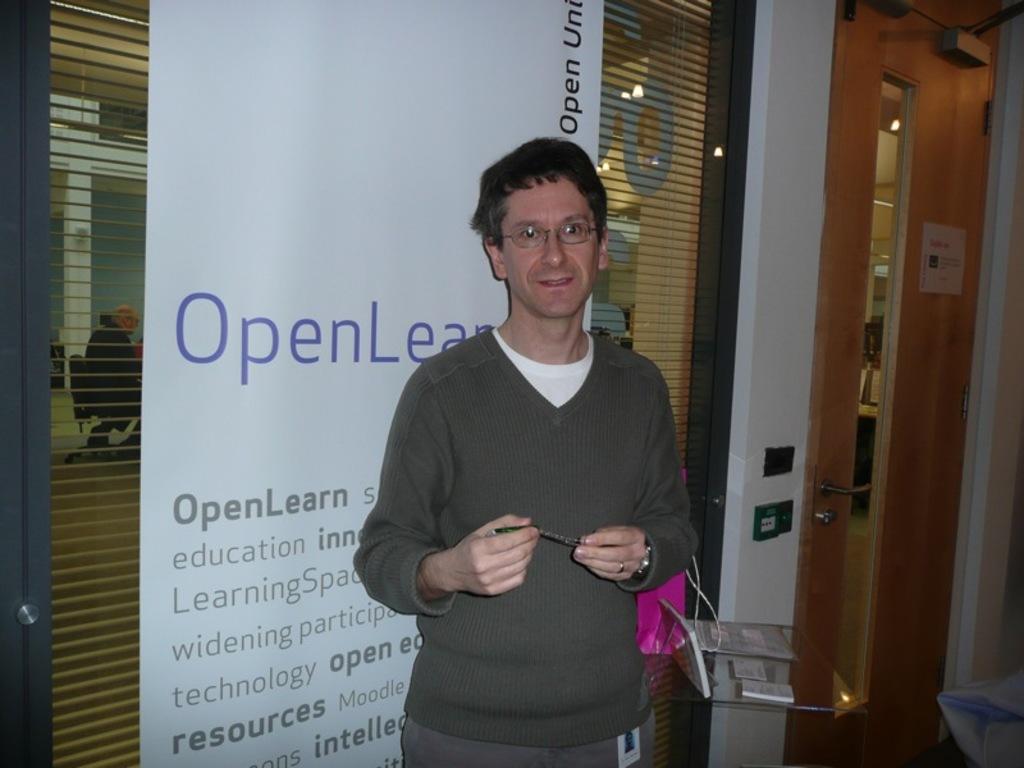Can you describe this image briefly? This image consists of a person standing in the middle. There's the door on the right side. There is a banner behind him. He is wearing sweaters, goggles. 